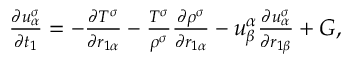Convert formula to latex. <formula><loc_0><loc_0><loc_500><loc_500>\begin{array} { r } { \begin{array} { r } { \frac { \partial u _ { \alpha } ^ { \sigma } } { \partial t _ { 1 } } = - \frac { \partial T ^ { \sigma } } { \partial r _ { 1 \alpha } } - \frac { T ^ { \sigma } } { \rho ^ { \sigma } } \frac { \partial \rho ^ { \sigma } } { \partial r _ { 1 \alpha } } - u _ { \beta } ^ { \alpha } \frac { \partial u _ { \alpha } ^ { \sigma } } { \partial r _ { 1 \beta } } + G , } \end{array} } \end{array}</formula> 